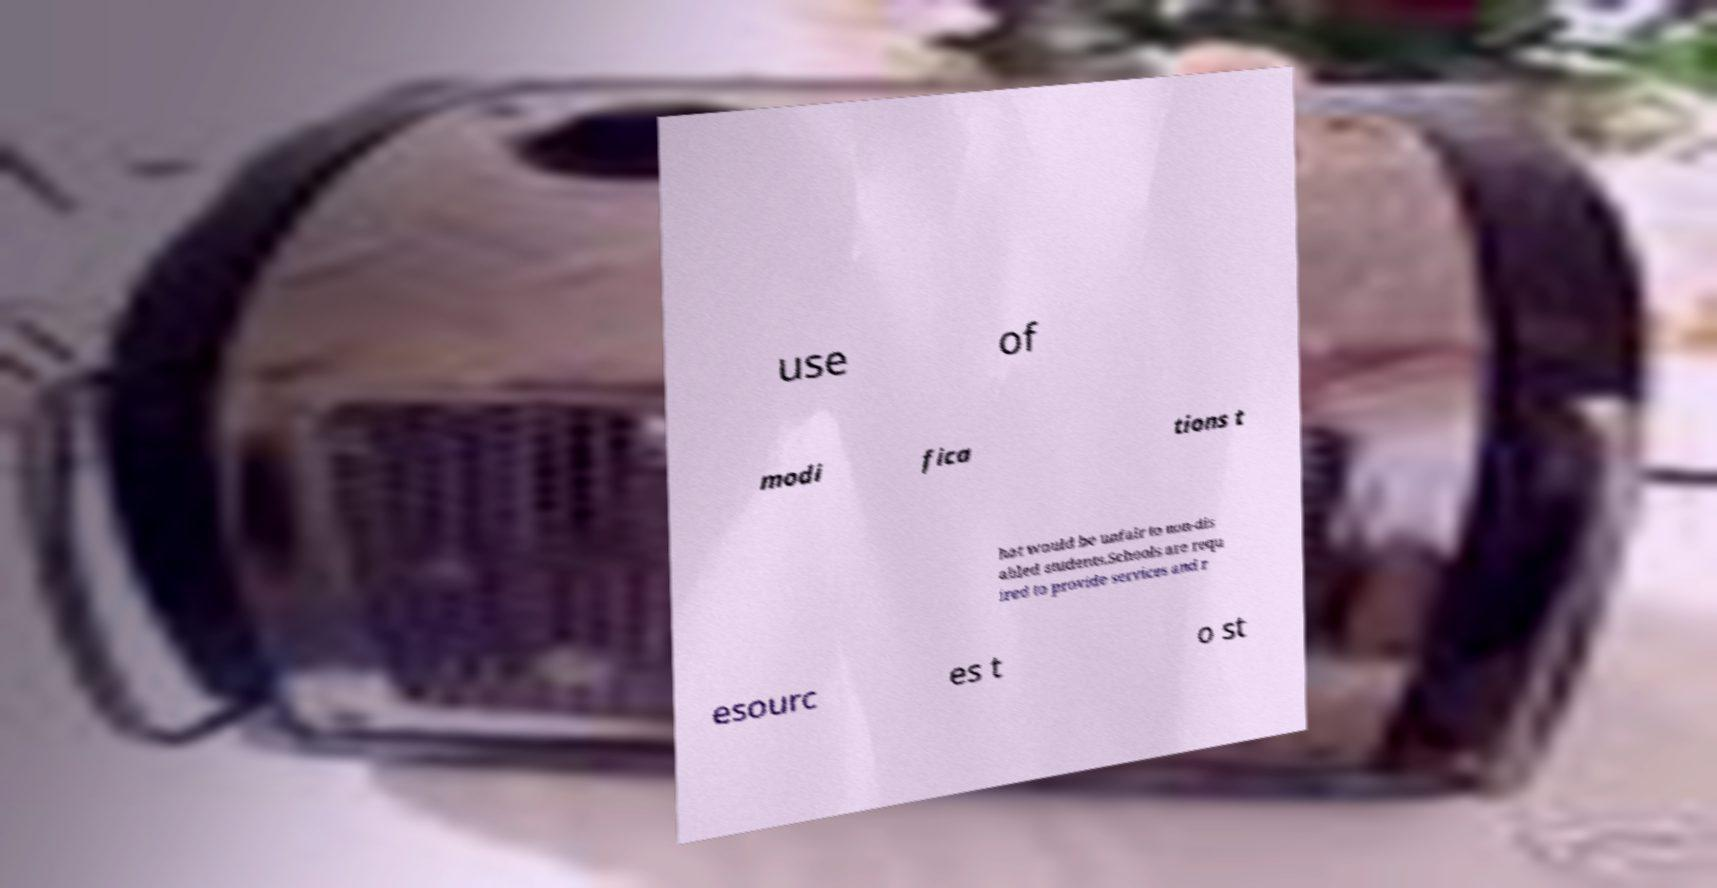I need the written content from this picture converted into text. Can you do that? use of modi fica tions t hat would be unfair to non-dis abled students.Schools are requ ired to provide services and r esourc es t o st 